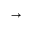<formula> <loc_0><loc_0><loc_500><loc_500>\vec { \nabla }</formula> 